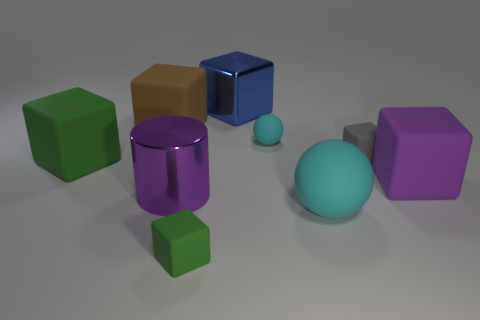Which objects are spherical and what sizes are they? There are two spherical objects in the image: one is a large light blue sphere, and the other is much smaller and appears in a teal color. 